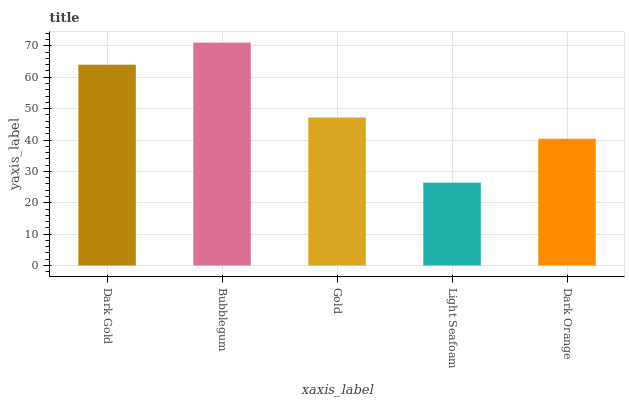Is Light Seafoam the minimum?
Answer yes or no. Yes. Is Bubblegum the maximum?
Answer yes or no. Yes. Is Gold the minimum?
Answer yes or no. No. Is Gold the maximum?
Answer yes or no. No. Is Bubblegum greater than Gold?
Answer yes or no. Yes. Is Gold less than Bubblegum?
Answer yes or no. Yes. Is Gold greater than Bubblegum?
Answer yes or no. No. Is Bubblegum less than Gold?
Answer yes or no. No. Is Gold the high median?
Answer yes or no. Yes. Is Gold the low median?
Answer yes or no. Yes. Is Dark Gold the high median?
Answer yes or no. No. Is Dark Gold the low median?
Answer yes or no. No. 